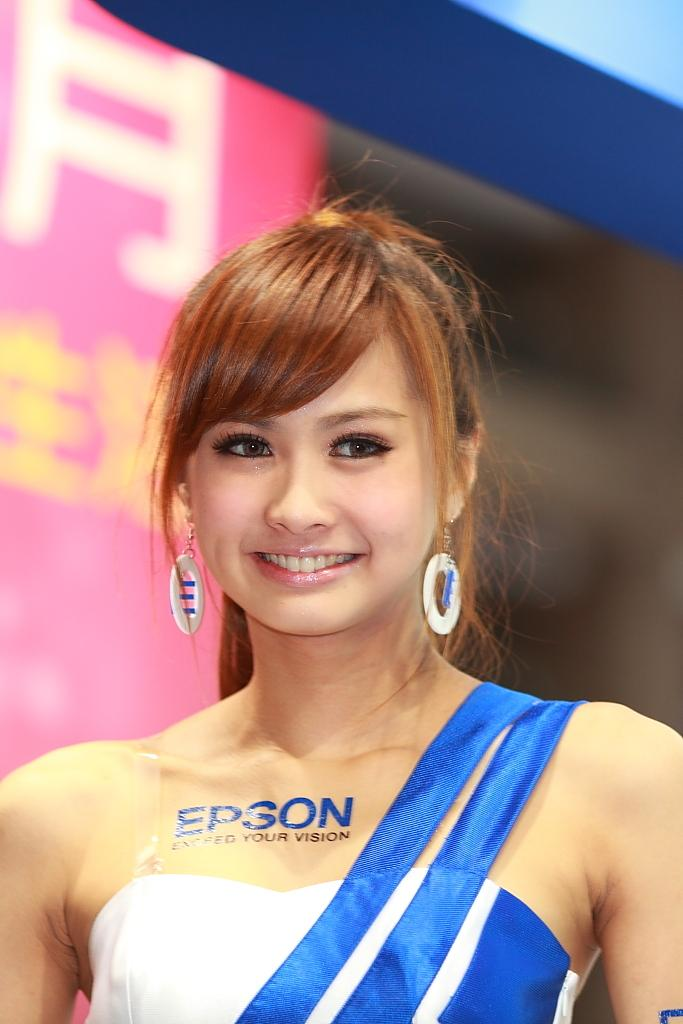<image>
Present a compact description of the photo's key features. a lady with the word Epson on her body 